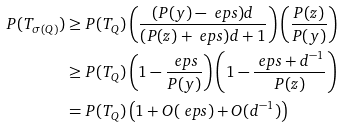<formula> <loc_0><loc_0><loc_500><loc_500>P ( T _ { \sigma ( Q ) } ) & \geq P ( T _ { Q } ) \left ( \frac { ( P ( y ) - \ e p s ) d } { ( P ( z ) + \ e p s ) d + 1 } \right ) \left ( \frac { P ( z ) } { P ( y ) } \right ) \\ & \geq P ( T _ { Q } ) \left ( 1 - \frac { \ e p s } { P ( y ) } \right ) \left ( 1 - \frac { \ e p s + d ^ { - 1 } } { P ( z ) } \right ) \\ & = P ( T _ { Q } ) \left ( 1 + O ( \ e p s ) + O ( d ^ { - 1 } ) \right )</formula> 